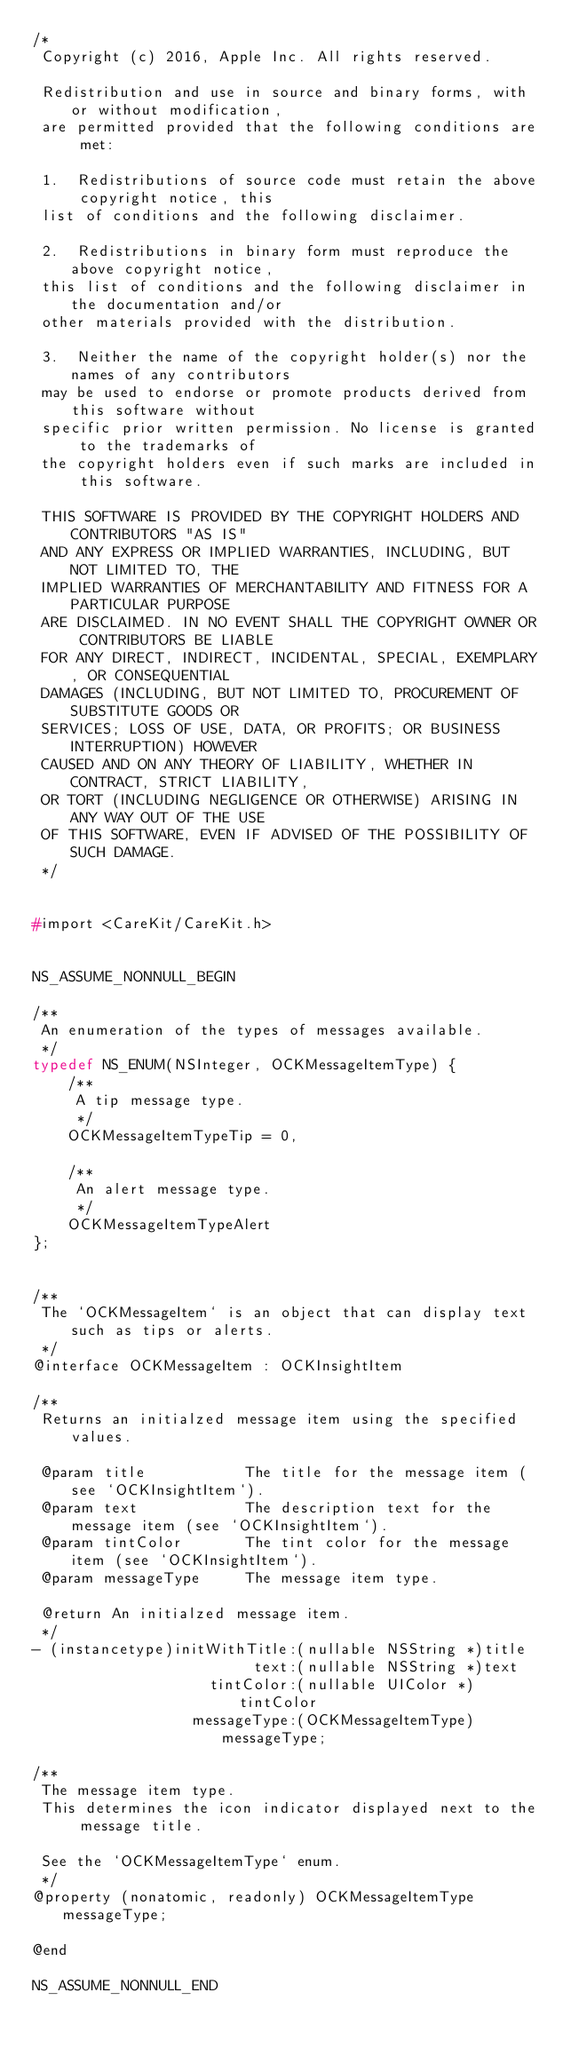Convert code to text. <code><loc_0><loc_0><loc_500><loc_500><_C_>/*
 Copyright (c) 2016, Apple Inc. All rights reserved.
 
 Redistribution and use in source and binary forms, with or without modification,
 are permitted provided that the following conditions are met:
 
 1.  Redistributions of source code must retain the above copyright notice, this
 list of conditions and the following disclaimer.
 
 2.  Redistributions in binary form must reproduce the above copyright notice,
 this list of conditions and the following disclaimer in the documentation and/or
 other materials provided with the distribution.
 
 3.  Neither the name of the copyright holder(s) nor the names of any contributors
 may be used to endorse or promote products derived from this software without
 specific prior written permission. No license is granted to the trademarks of
 the copyright holders even if such marks are included in this software.
 
 THIS SOFTWARE IS PROVIDED BY THE COPYRIGHT HOLDERS AND CONTRIBUTORS "AS IS"
 AND ANY EXPRESS OR IMPLIED WARRANTIES, INCLUDING, BUT NOT LIMITED TO, THE
 IMPLIED WARRANTIES OF MERCHANTABILITY AND FITNESS FOR A PARTICULAR PURPOSE
 ARE DISCLAIMED. IN NO EVENT SHALL THE COPYRIGHT OWNER OR CONTRIBUTORS BE LIABLE
 FOR ANY DIRECT, INDIRECT, INCIDENTAL, SPECIAL, EXEMPLARY, OR CONSEQUENTIAL
 DAMAGES (INCLUDING, BUT NOT LIMITED TO, PROCUREMENT OF SUBSTITUTE GOODS OR
 SERVICES; LOSS OF USE, DATA, OR PROFITS; OR BUSINESS INTERRUPTION) HOWEVER
 CAUSED AND ON ANY THEORY OF LIABILITY, WHETHER IN CONTRACT, STRICT LIABILITY,
 OR TORT (INCLUDING NEGLIGENCE OR OTHERWISE) ARISING IN ANY WAY OUT OF THE USE
 OF THIS SOFTWARE, EVEN IF ADVISED OF THE POSSIBILITY OF SUCH DAMAGE.
 */


#import <CareKit/CareKit.h>


NS_ASSUME_NONNULL_BEGIN

/**
 An enumeration of the types of messages available.
 */
typedef NS_ENUM(NSInteger, OCKMessageItemType) {
    /**
     A tip message type.
     */
    OCKMessageItemTypeTip = 0,
    
    /**
     An alert message type.
     */
    OCKMessageItemTypeAlert
};


/**
 The `OCKMessageItem` is an object that can display text such as tips or alerts.
 */
@interface OCKMessageItem : OCKInsightItem

/**
 Returns an initialzed message item using the specified values.
 
 @param title           The title for the message item (see `OCKInsightItem`).
 @param text            The description text for the message item (see `OCKInsightItem`).
 @param tintColor       The tint color for the message item (see `OCKInsightItem`).
 @param messageType     The message item type.
 
 @return An initialzed message item.
 */
- (instancetype)initWithTitle:(nullable NSString *)title
                         text:(nullable NSString *)text
                    tintColor:(nullable UIColor *)tintColor
                  messageType:(OCKMessageItemType)messageType;

/**
 The message item type.
 This determines the icon indicator displayed next to the message title.
 
 See the `OCKMessageItemType` enum.
 */
@property (nonatomic, readonly) OCKMessageItemType messageType;

@end

NS_ASSUME_NONNULL_END
</code> 